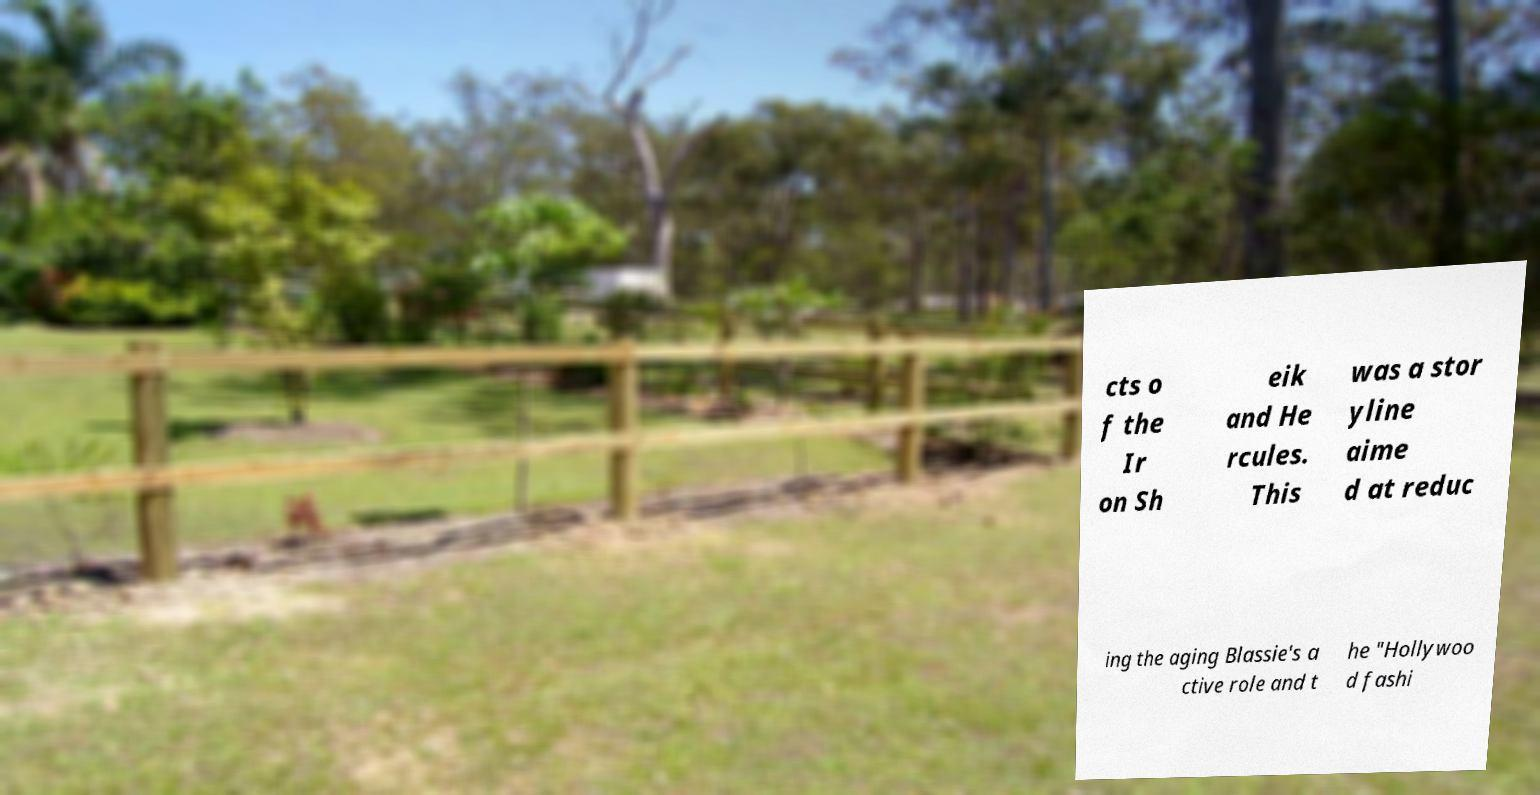Could you assist in decoding the text presented in this image and type it out clearly? cts o f the Ir on Sh eik and He rcules. This was a stor yline aime d at reduc ing the aging Blassie's a ctive role and t he "Hollywoo d fashi 